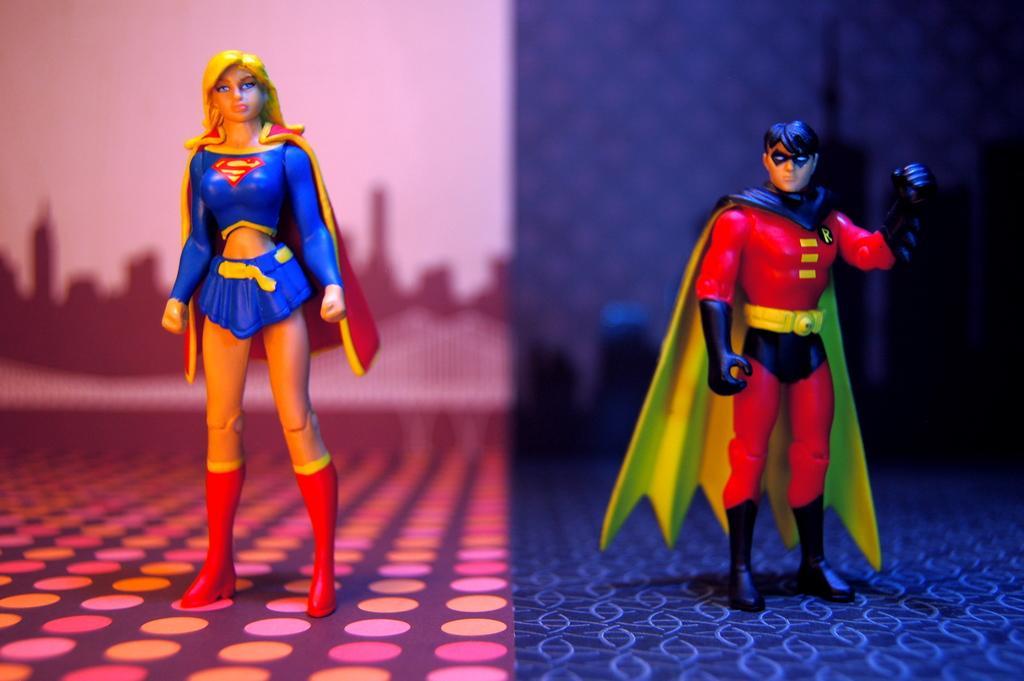Could you give a brief overview of what you see in this image? On the left side it's a toy of a superhuman, this person wore a blue color dress. On the right side there is a person standing, this person wore a red color dress. 